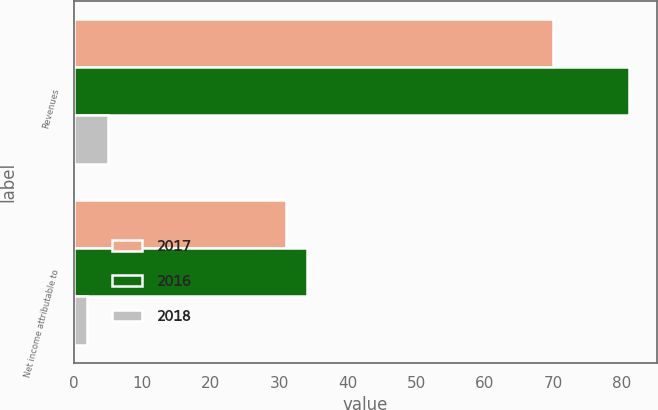Convert chart. <chart><loc_0><loc_0><loc_500><loc_500><stacked_bar_chart><ecel><fcel>Revenues<fcel>Net income attributable to<nl><fcel>2017<fcel>70<fcel>31<nl><fcel>2016<fcel>81<fcel>34<nl><fcel>2018<fcel>5<fcel>2<nl></chart> 